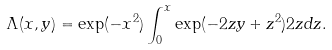<formula> <loc_0><loc_0><loc_500><loc_500>\Lambda ( x , y ) = \exp ( - x ^ { 2 } ) \int _ { 0 } ^ { x } \exp ( - 2 z y + z ^ { 2 } ) 2 z d z .</formula> 